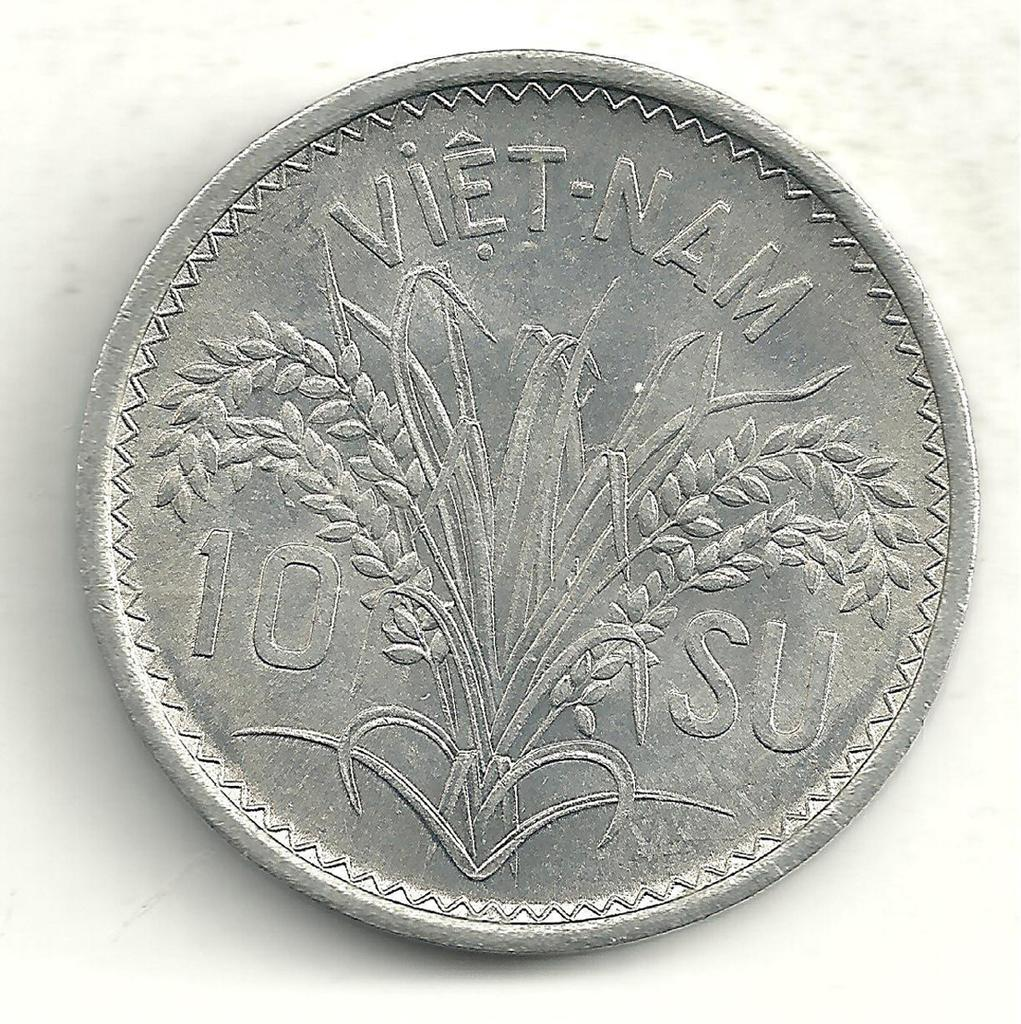<image>
Summarize the visual content of the image. A silver coin from Vietnam that says 10 SU.. 